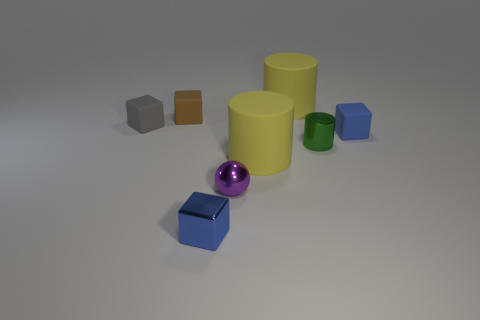Are the tiny brown cube and the gray object made of the same material?
Keep it short and to the point. Yes. What number of objects are either tiny blue cubes that are to the right of the small purple thing or big yellow rubber cylinders that are in front of the blue matte block?
Make the answer very short. 2. Are there any purple shiny things of the same size as the gray cube?
Make the answer very short. Yes. There is another small shiny object that is the same shape as the small gray thing; what color is it?
Keep it short and to the point. Blue. There is a big yellow object in front of the tiny green thing; is there a green metal cylinder that is in front of it?
Your answer should be very brief. No. Does the small rubber thing behind the gray object have the same shape as the tiny purple object?
Provide a succinct answer. No. The tiny blue rubber thing is what shape?
Your answer should be very brief. Cube. How many small brown cubes are made of the same material as the small gray cube?
Your answer should be very brief. 1. There is a tiny sphere; is it the same color as the small rubber thing to the right of the metal cube?
Keep it short and to the point. No. How many yellow things are there?
Your response must be concise. 2. 